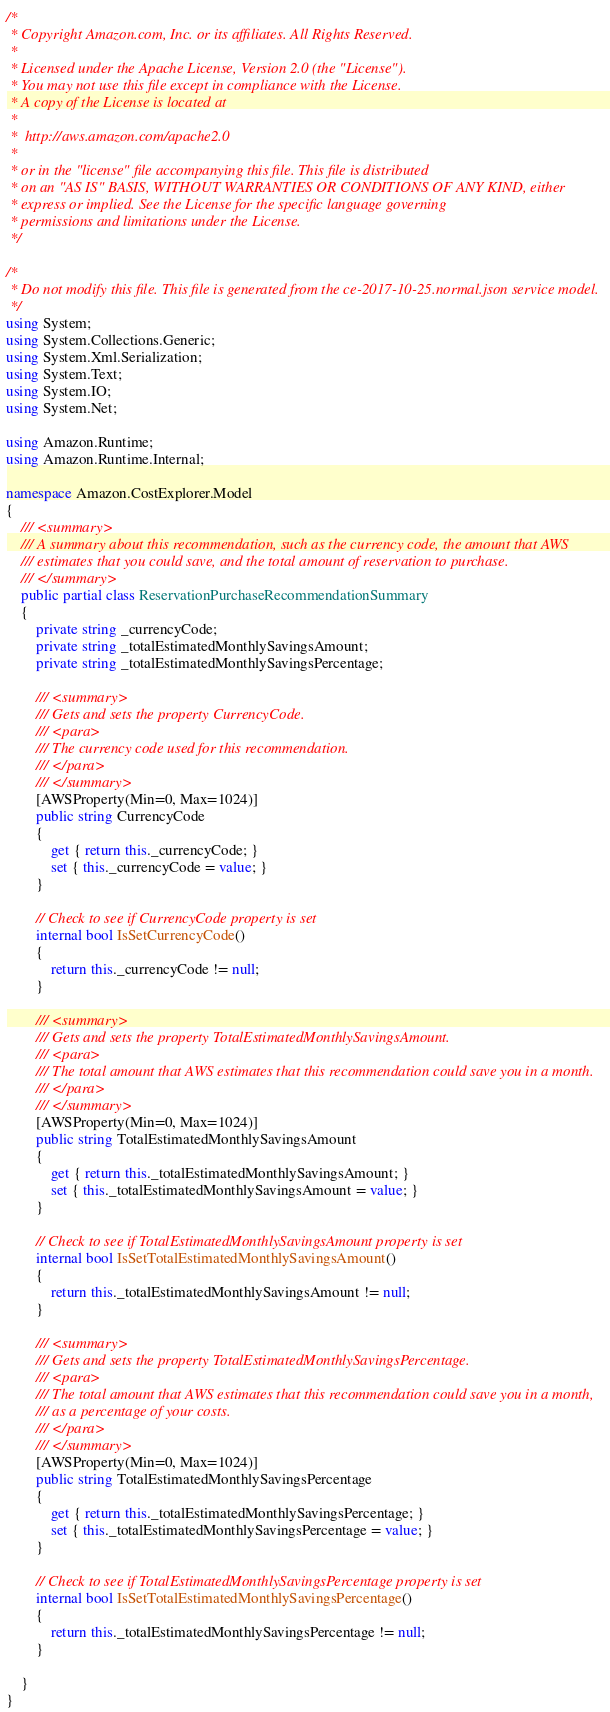Convert code to text. <code><loc_0><loc_0><loc_500><loc_500><_C#_>/*
 * Copyright Amazon.com, Inc. or its affiliates. All Rights Reserved.
 * 
 * Licensed under the Apache License, Version 2.0 (the "License").
 * You may not use this file except in compliance with the License.
 * A copy of the License is located at
 * 
 *  http://aws.amazon.com/apache2.0
 * 
 * or in the "license" file accompanying this file. This file is distributed
 * on an "AS IS" BASIS, WITHOUT WARRANTIES OR CONDITIONS OF ANY KIND, either
 * express or implied. See the License for the specific language governing
 * permissions and limitations under the License.
 */

/*
 * Do not modify this file. This file is generated from the ce-2017-10-25.normal.json service model.
 */
using System;
using System.Collections.Generic;
using System.Xml.Serialization;
using System.Text;
using System.IO;
using System.Net;

using Amazon.Runtime;
using Amazon.Runtime.Internal;

namespace Amazon.CostExplorer.Model
{
    /// <summary>
    /// A summary about this recommendation, such as the currency code, the amount that AWS
    /// estimates that you could save, and the total amount of reservation to purchase.
    /// </summary>
    public partial class ReservationPurchaseRecommendationSummary
    {
        private string _currencyCode;
        private string _totalEstimatedMonthlySavingsAmount;
        private string _totalEstimatedMonthlySavingsPercentage;

        /// <summary>
        /// Gets and sets the property CurrencyCode. 
        /// <para>
        /// The currency code used for this recommendation.
        /// </para>
        /// </summary>
        [AWSProperty(Min=0, Max=1024)]
        public string CurrencyCode
        {
            get { return this._currencyCode; }
            set { this._currencyCode = value; }
        }

        // Check to see if CurrencyCode property is set
        internal bool IsSetCurrencyCode()
        {
            return this._currencyCode != null;
        }

        /// <summary>
        /// Gets and sets the property TotalEstimatedMonthlySavingsAmount. 
        /// <para>
        /// The total amount that AWS estimates that this recommendation could save you in a month.
        /// </para>
        /// </summary>
        [AWSProperty(Min=0, Max=1024)]
        public string TotalEstimatedMonthlySavingsAmount
        {
            get { return this._totalEstimatedMonthlySavingsAmount; }
            set { this._totalEstimatedMonthlySavingsAmount = value; }
        }

        // Check to see if TotalEstimatedMonthlySavingsAmount property is set
        internal bool IsSetTotalEstimatedMonthlySavingsAmount()
        {
            return this._totalEstimatedMonthlySavingsAmount != null;
        }

        /// <summary>
        /// Gets and sets the property TotalEstimatedMonthlySavingsPercentage. 
        /// <para>
        /// The total amount that AWS estimates that this recommendation could save you in a month,
        /// as a percentage of your costs.
        /// </para>
        /// </summary>
        [AWSProperty(Min=0, Max=1024)]
        public string TotalEstimatedMonthlySavingsPercentage
        {
            get { return this._totalEstimatedMonthlySavingsPercentage; }
            set { this._totalEstimatedMonthlySavingsPercentage = value; }
        }

        // Check to see if TotalEstimatedMonthlySavingsPercentage property is set
        internal bool IsSetTotalEstimatedMonthlySavingsPercentage()
        {
            return this._totalEstimatedMonthlySavingsPercentage != null;
        }

    }
}</code> 